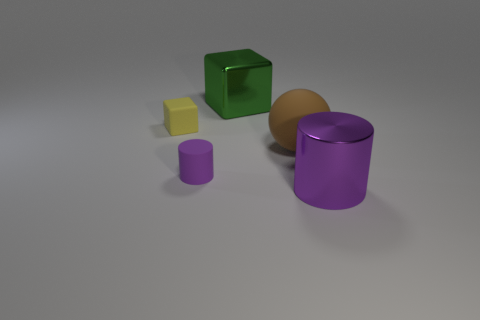What number of other objects are there of the same color as the matte cylinder?
Give a very brief answer. 1. Is the shape of the small yellow object the same as the big metallic object that is behind the large cylinder?
Your answer should be compact. Yes. Are there fewer tiny purple cylinders that are left of the yellow rubber object than tiny purple matte cylinders in front of the large purple thing?
Keep it short and to the point. No. Is there any other thing that has the same shape as the purple shiny thing?
Provide a succinct answer. Yes. Do the yellow object and the purple metal thing have the same shape?
Make the answer very short. No. Is there anything else that is the same material as the green block?
Offer a terse response. Yes. The purple metallic cylinder is what size?
Your answer should be compact. Large. There is a object that is both in front of the brown object and left of the purple metallic cylinder; what color is it?
Provide a short and direct response. Purple. Is the number of small blue spheres greater than the number of purple metal objects?
Ensure brevity in your answer.  No. How many objects are tiny yellow blocks or objects that are on the right side of the yellow rubber cube?
Give a very brief answer. 5. 